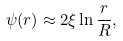Convert formula to latex. <formula><loc_0><loc_0><loc_500><loc_500>\psi ( r ) \approx 2 \xi \ln \frac { r } { R } ,</formula> 